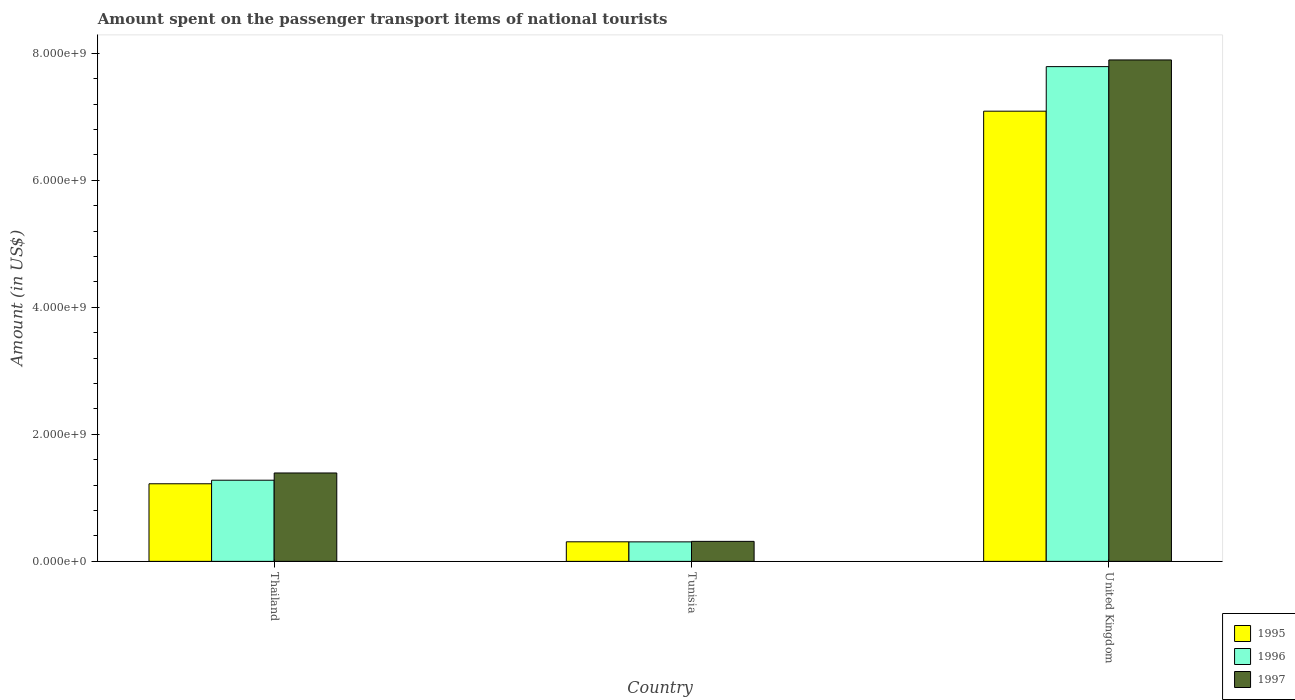How many groups of bars are there?
Your response must be concise. 3. Are the number of bars on each tick of the X-axis equal?
Provide a succinct answer. Yes. How many bars are there on the 3rd tick from the left?
Provide a short and direct response. 3. What is the label of the 1st group of bars from the left?
Keep it short and to the point. Thailand. What is the amount spent on the passenger transport items of national tourists in 1996 in Tunisia?
Offer a very short reply. 3.07e+08. Across all countries, what is the maximum amount spent on the passenger transport items of national tourists in 1997?
Give a very brief answer. 7.90e+09. Across all countries, what is the minimum amount spent on the passenger transport items of national tourists in 1997?
Your answer should be compact. 3.15e+08. In which country was the amount spent on the passenger transport items of national tourists in 1996 minimum?
Keep it short and to the point. Tunisia. What is the total amount spent on the passenger transport items of national tourists in 1997 in the graph?
Give a very brief answer. 9.60e+09. What is the difference between the amount spent on the passenger transport items of national tourists in 1996 in Thailand and that in United Kingdom?
Give a very brief answer. -6.51e+09. What is the difference between the amount spent on the passenger transport items of national tourists in 1995 in United Kingdom and the amount spent on the passenger transport items of national tourists in 1997 in Tunisia?
Your answer should be very brief. 6.78e+09. What is the average amount spent on the passenger transport items of national tourists in 1995 per country?
Keep it short and to the point. 2.87e+09. What is the difference between the amount spent on the passenger transport items of national tourists of/in 1995 and amount spent on the passenger transport items of national tourists of/in 1997 in United Kingdom?
Offer a terse response. -8.07e+08. What is the ratio of the amount spent on the passenger transport items of national tourists in 1995 in Thailand to that in Tunisia?
Your response must be concise. 3.97. Is the amount spent on the passenger transport items of national tourists in 1996 in Tunisia less than that in United Kingdom?
Offer a terse response. Yes. What is the difference between the highest and the second highest amount spent on the passenger transport items of national tourists in 1996?
Offer a very short reply. 6.51e+09. What is the difference between the highest and the lowest amount spent on the passenger transport items of national tourists in 1996?
Provide a succinct answer. 7.48e+09. In how many countries, is the amount spent on the passenger transport items of national tourists in 1997 greater than the average amount spent on the passenger transport items of national tourists in 1997 taken over all countries?
Your answer should be very brief. 1. Is it the case that in every country, the sum of the amount spent on the passenger transport items of national tourists in 1995 and amount spent on the passenger transport items of national tourists in 1997 is greater than the amount spent on the passenger transport items of national tourists in 1996?
Keep it short and to the point. Yes. How many bars are there?
Give a very brief answer. 9. Are all the bars in the graph horizontal?
Give a very brief answer. No. How many countries are there in the graph?
Provide a short and direct response. 3. Are the values on the major ticks of Y-axis written in scientific E-notation?
Make the answer very short. Yes. Where does the legend appear in the graph?
Provide a short and direct response. Bottom right. How many legend labels are there?
Keep it short and to the point. 3. What is the title of the graph?
Make the answer very short. Amount spent on the passenger transport items of national tourists. What is the label or title of the Y-axis?
Offer a very short reply. Amount (in US$). What is the Amount (in US$) of 1995 in Thailand?
Keep it short and to the point. 1.22e+09. What is the Amount (in US$) in 1996 in Thailand?
Your answer should be compact. 1.28e+09. What is the Amount (in US$) in 1997 in Thailand?
Keep it short and to the point. 1.39e+09. What is the Amount (in US$) of 1995 in Tunisia?
Offer a terse response. 3.08e+08. What is the Amount (in US$) in 1996 in Tunisia?
Provide a short and direct response. 3.07e+08. What is the Amount (in US$) of 1997 in Tunisia?
Your answer should be compact. 3.15e+08. What is the Amount (in US$) of 1995 in United Kingdom?
Offer a terse response. 7.09e+09. What is the Amount (in US$) of 1996 in United Kingdom?
Give a very brief answer. 7.79e+09. What is the Amount (in US$) in 1997 in United Kingdom?
Your answer should be very brief. 7.90e+09. Across all countries, what is the maximum Amount (in US$) of 1995?
Provide a succinct answer. 7.09e+09. Across all countries, what is the maximum Amount (in US$) of 1996?
Your response must be concise. 7.79e+09. Across all countries, what is the maximum Amount (in US$) of 1997?
Keep it short and to the point. 7.90e+09. Across all countries, what is the minimum Amount (in US$) in 1995?
Ensure brevity in your answer.  3.08e+08. Across all countries, what is the minimum Amount (in US$) of 1996?
Provide a short and direct response. 3.07e+08. Across all countries, what is the minimum Amount (in US$) of 1997?
Offer a very short reply. 3.15e+08. What is the total Amount (in US$) in 1995 in the graph?
Provide a short and direct response. 8.62e+09. What is the total Amount (in US$) of 1996 in the graph?
Ensure brevity in your answer.  9.38e+09. What is the total Amount (in US$) of 1997 in the graph?
Keep it short and to the point. 9.60e+09. What is the difference between the Amount (in US$) of 1995 in Thailand and that in Tunisia?
Ensure brevity in your answer.  9.14e+08. What is the difference between the Amount (in US$) in 1996 in Thailand and that in Tunisia?
Your answer should be very brief. 9.71e+08. What is the difference between the Amount (in US$) of 1997 in Thailand and that in Tunisia?
Offer a very short reply. 1.08e+09. What is the difference between the Amount (in US$) in 1995 in Thailand and that in United Kingdom?
Your answer should be compact. -5.87e+09. What is the difference between the Amount (in US$) in 1996 in Thailand and that in United Kingdom?
Ensure brevity in your answer.  -6.51e+09. What is the difference between the Amount (in US$) of 1997 in Thailand and that in United Kingdom?
Make the answer very short. -6.50e+09. What is the difference between the Amount (in US$) in 1995 in Tunisia and that in United Kingdom?
Provide a succinct answer. -6.78e+09. What is the difference between the Amount (in US$) of 1996 in Tunisia and that in United Kingdom?
Make the answer very short. -7.48e+09. What is the difference between the Amount (in US$) of 1997 in Tunisia and that in United Kingdom?
Offer a very short reply. -7.58e+09. What is the difference between the Amount (in US$) of 1995 in Thailand and the Amount (in US$) of 1996 in Tunisia?
Your answer should be compact. 9.15e+08. What is the difference between the Amount (in US$) of 1995 in Thailand and the Amount (in US$) of 1997 in Tunisia?
Make the answer very short. 9.07e+08. What is the difference between the Amount (in US$) in 1996 in Thailand and the Amount (in US$) in 1997 in Tunisia?
Give a very brief answer. 9.63e+08. What is the difference between the Amount (in US$) in 1995 in Thailand and the Amount (in US$) in 1996 in United Kingdom?
Offer a terse response. -6.57e+09. What is the difference between the Amount (in US$) in 1995 in Thailand and the Amount (in US$) in 1997 in United Kingdom?
Ensure brevity in your answer.  -6.68e+09. What is the difference between the Amount (in US$) in 1996 in Thailand and the Amount (in US$) in 1997 in United Kingdom?
Offer a terse response. -6.62e+09. What is the difference between the Amount (in US$) in 1995 in Tunisia and the Amount (in US$) in 1996 in United Kingdom?
Ensure brevity in your answer.  -7.48e+09. What is the difference between the Amount (in US$) in 1995 in Tunisia and the Amount (in US$) in 1997 in United Kingdom?
Provide a short and direct response. -7.59e+09. What is the difference between the Amount (in US$) of 1996 in Tunisia and the Amount (in US$) of 1997 in United Kingdom?
Ensure brevity in your answer.  -7.59e+09. What is the average Amount (in US$) in 1995 per country?
Your response must be concise. 2.87e+09. What is the average Amount (in US$) of 1996 per country?
Make the answer very short. 3.13e+09. What is the average Amount (in US$) of 1997 per country?
Offer a terse response. 3.20e+09. What is the difference between the Amount (in US$) in 1995 and Amount (in US$) in 1996 in Thailand?
Your answer should be compact. -5.60e+07. What is the difference between the Amount (in US$) in 1995 and Amount (in US$) in 1997 in Thailand?
Provide a short and direct response. -1.70e+08. What is the difference between the Amount (in US$) in 1996 and Amount (in US$) in 1997 in Thailand?
Your answer should be compact. -1.14e+08. What is the difference between the Amount (in US$) in 1995 and Amount (in US$) in 1996 in Tunisia?
Provide a short and direct response. 1.00e+06. What is the difference between the Amount (in US$) of 1995 and Amount (in US$) of 1997 in Tunisia?
Keep it short and to the point. -7.00e+06. What is the difference between the Amount (in US$) of 1996 and Amount (in US$) of 1997 in Tunisia?
Your response must be concise. -8.00e+06. What is the difference between the Amount (in US$) of 1995 and Amount (in US$) of 1996 in United Kingdom?
Offer a very short reply. -7.02e+08. What is the difference between the Amount (in US$) in 1995 and Amount (in US$) in 1997 in United Kingdom?
Provide a succinct answer. -8.07e+08. What is the difference between the Amount (in US$) of 1996 and Amount (in US$) of 1997 in United Kingdom?
Ensure brevity in your answer.  -1.05e+08. What is the ratio of the Amount (in US$) of 1995 in Thailand to that in Tunisia?
Give a very brief answer. 3.97. What is the ratio of the Amount (in US$) of 1996 in Thailand to that in Tunisia?
Provide a short and direct response. 4.16. What is the ratio of the Amount (in US$) in 1997 in Thailand to that in Tunisia?
Provide a succinct answer. 4.42. What is the ratio of the Amount (in US$) in 1995 in Thailand to that in United Kingdom?
Your answer should be compact. 0.17. What is the ratio of the Amount (in US$) of 1996 in Thailand to that in United Kingdom?
Your answer should be compact. 0.16. What is the ratio of the Amount (in US$) of 1997 in Thailand to that in United Kingdom?
Provide a short and direct response. 0.18. What is the ratio of the Amount (in US$) in 1995 in Tunisia to that in United Kingdom?
Provide a succinct answer. 0.04. What is the ratio of the Amount (in US$) of 1996 in Tunisia to that in United Kingdom?
Give a very brief answer. 0.04. What is the ratio of the Amount (in US$) in 1997 in Tunisia to that in United Kingdom?
Provide a succinct answer. 0.04. What is the difference between the highest and the second highest Amount (in US$) in 1995?
Keep it short and to the point. 5.87e+09. What is the difference between the highest and the second highest Amount (in US$) of 1996?
Offer a very short reply. 6.51e+09. What is the difference between the highest and the second highest Amount (in US$) of 1997?
Your answer should be compact. 6.50e+09. What is the difference between the highest and the lowest Amount (in US$) in 1995?
Provide a short and direct response. 6.78e+09. What is the difference between the highest and the lowest Amount (in US$) of 1996?
Offer a terse response. 7.48e+09. What is the difference between the highest and the lowest Amount (in US$) in 1997?
Ensure brevity in your answer.  7.58e+09. 